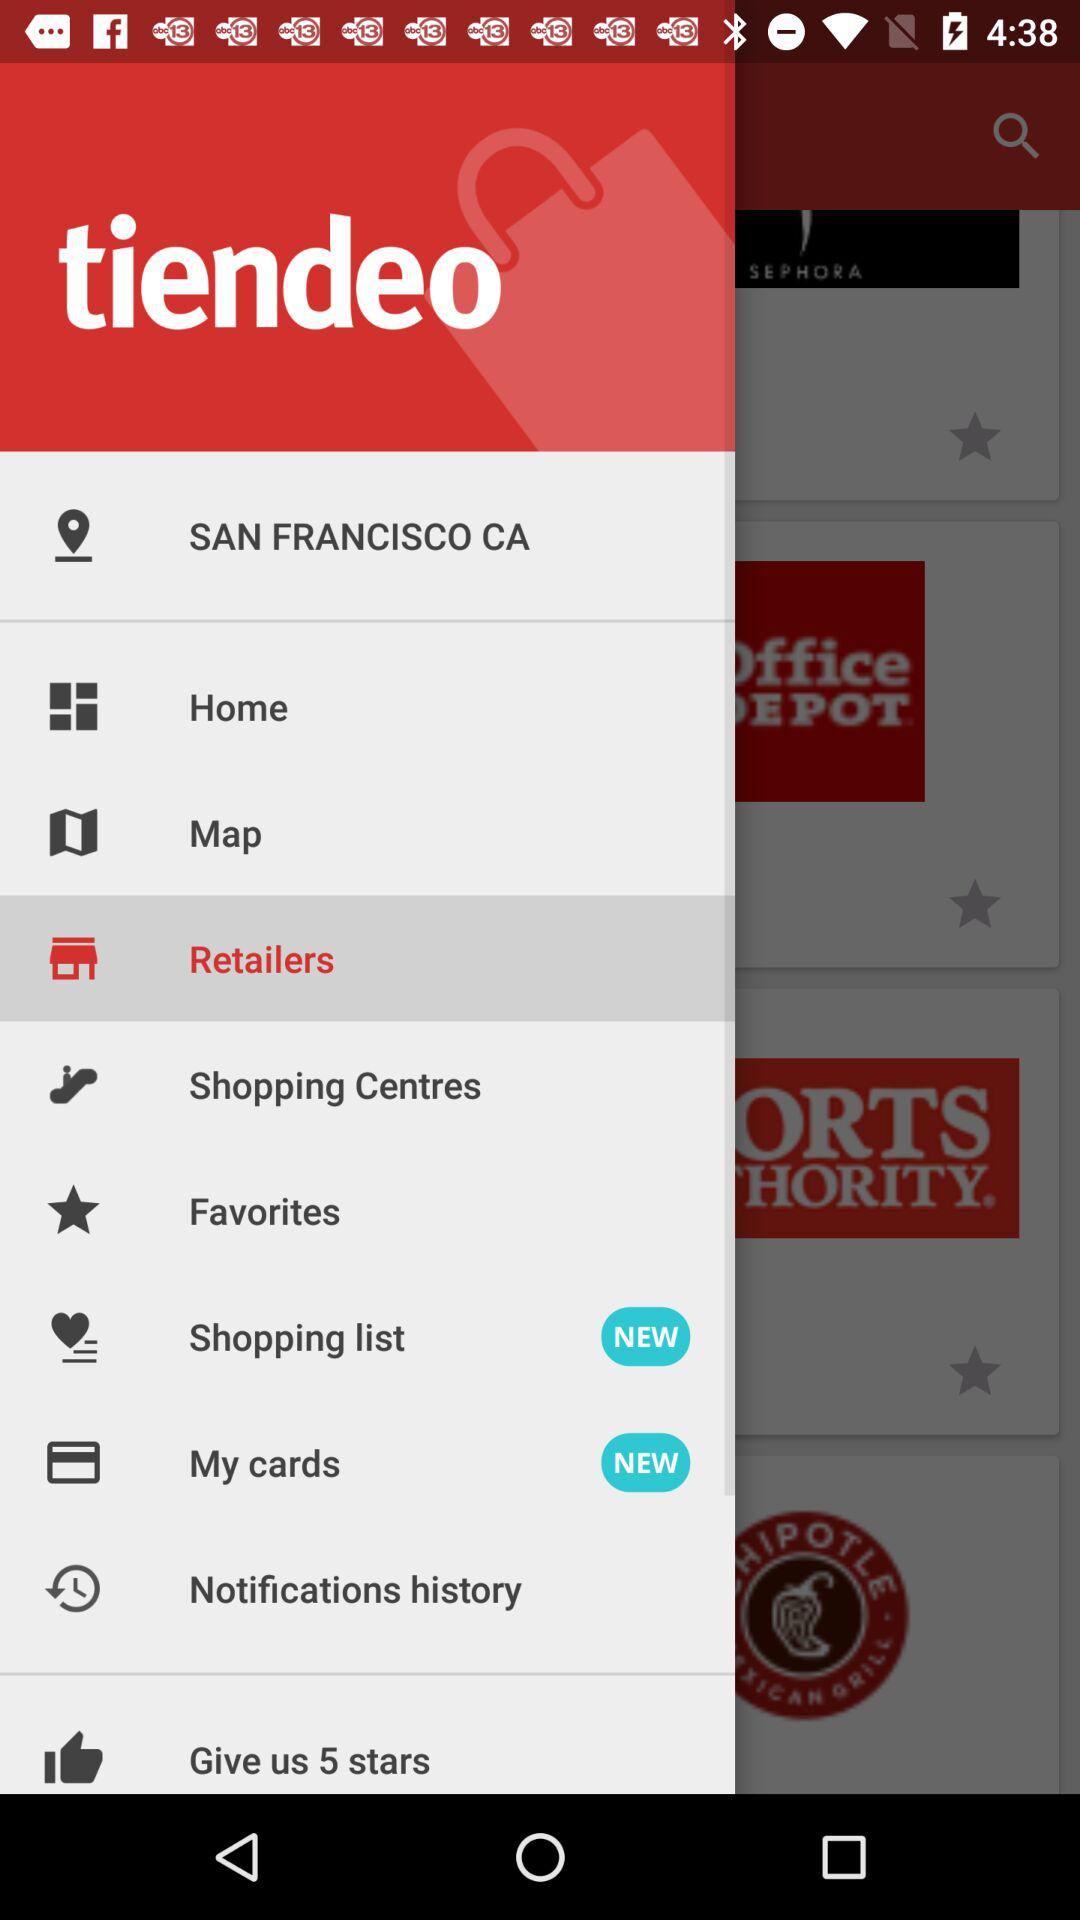Which option is selected? The selected option is retailers. 